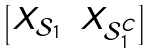Convert formula to latex. <formula><loc_0><loc_0><loc_500><loc_500>\begin{bmatrix} X _ { \mathcal { S } _ { 1 } } & X _ { \mathcal { S } _ { 1 } ^ { C } } \end{bmatrix}</formula> 